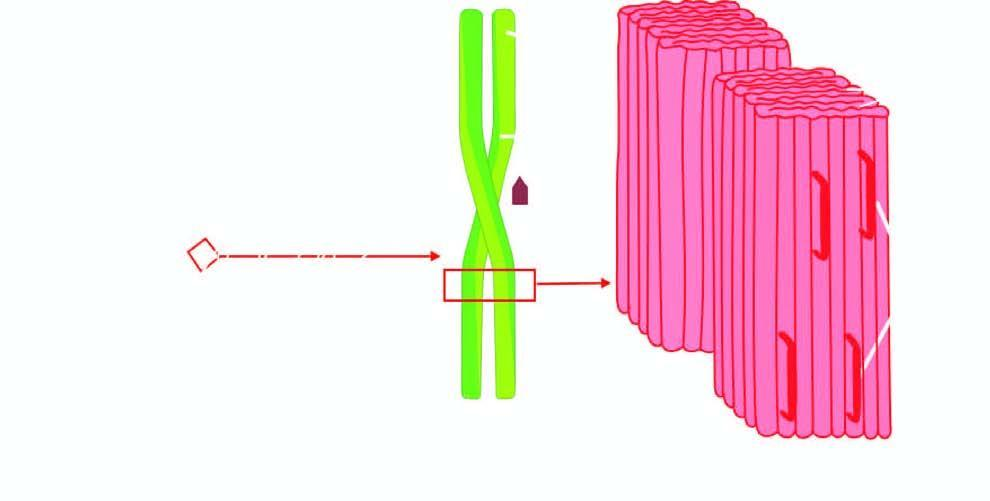does p-component have a pentagonal or doughnut profile?
Answer the question using a single word or phrase. Yes 